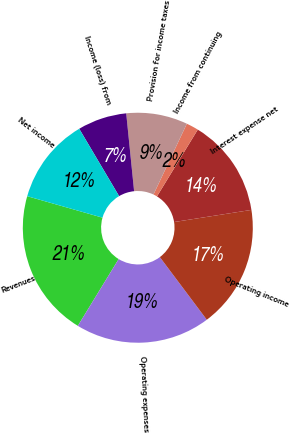Convert chart. <chart><loc_0><loc_0><loc_500><loc_500><pie_chart><fcel>Revenues<fcel>Operating expenses<fcel>Operating income<fcel>Interest expense net<fcel>Income from continuing<fcel>Provision for income taxes<fcel>Income (loss) from<fcel>Net income<nl><fcel>20.69%<fcel>18.97%<fcel>17.24%<fcel>13.79%<fcel>1.72%<fcel>8.62%<fcel>6.9%<fcel>12.07%<nl></chart> 